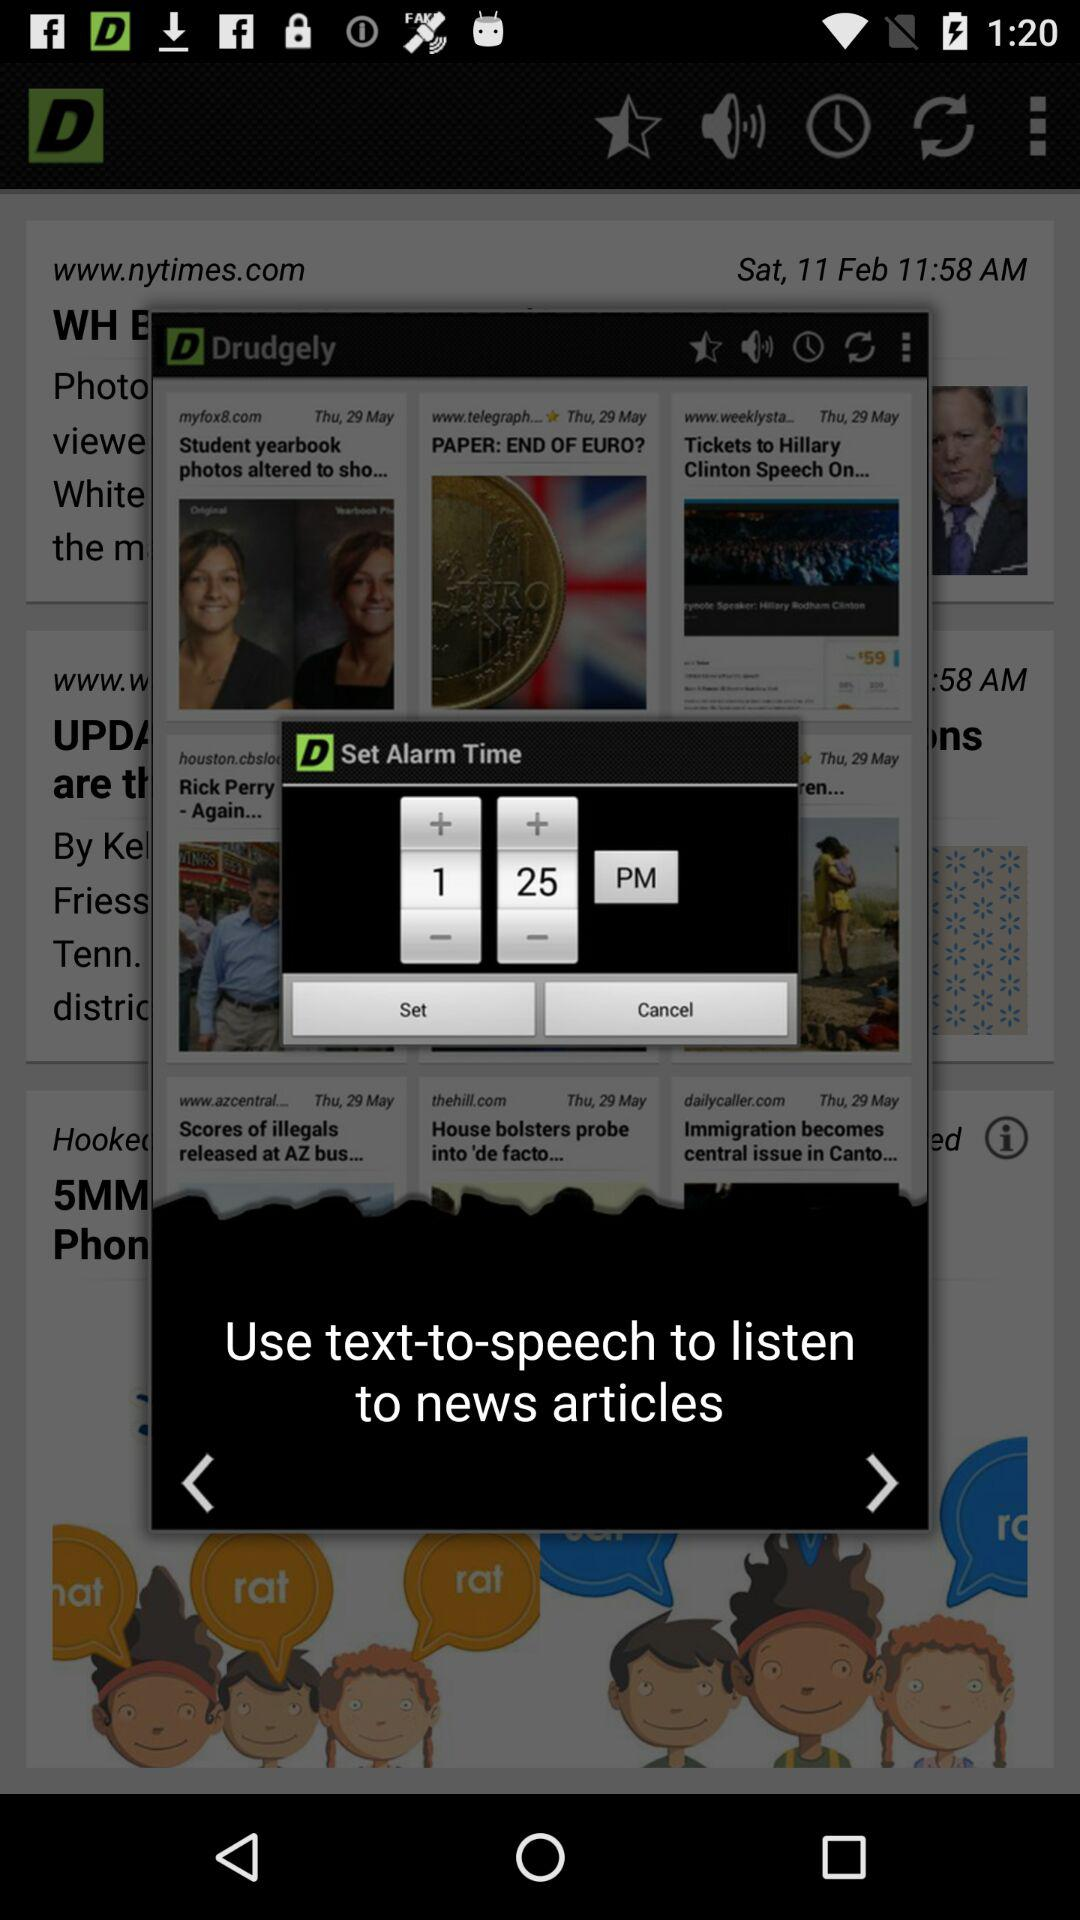What is the name of the application? The name of the application is "Drudgely". 